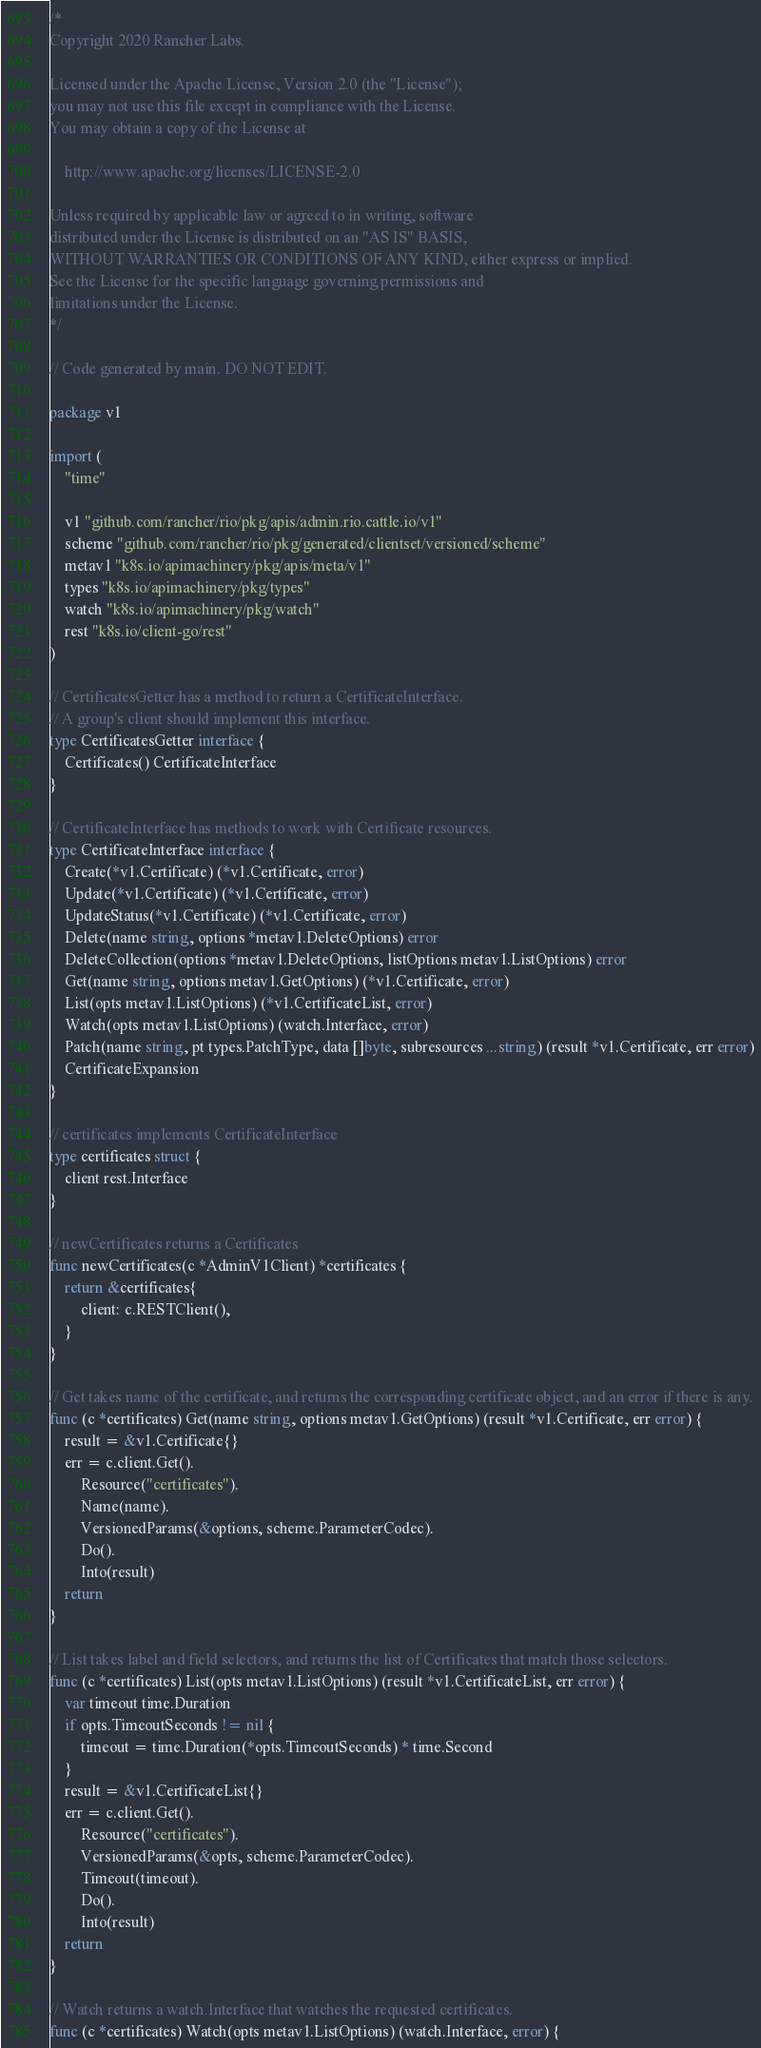Convert code to text. <code><loc_0><loc_0><loc_500><loc_500><_Go_>/*
Copyright 2020 Rancher Labs.

Licensed under the Apache License, Version 2.0 (the "License");
you may not use this file except in compliance with the License.
You may obtain a copy of the License at

    http://www.apache.org/licenses/LICENSE-2.0

Unless required by applicable law or agreed to in writing, software
distributed under the License is distributed on an "AS IS" BASIS,
WITHOUT WARRANTIES OR CONDITIONS OF ANY KIND, either express or implied.
See the License for the specific language governing permissions and
limitations under the License.
*/

// Code generated by main. DO NOT EDIT.

package v1

import (
	"time"

	v1 "github.com/rancher/rio/pkg/apis/admin.rio.cattle.io/v1"
	scheme "github.com/rancher/rio/pkg/generated/clientset/versioned/scheme"
	metav1 "k8s.io/apimachinery/pkg/apis/meta/v1"
	types "k8s.io/apimachinery/pkg/types"
	watch "k8s.io/apimachinery/pkg/watch"
	rest "k8s.io/client-go/rest"
)

// CertificatesGetter has a method to return a CertificateInterface.
// A group's client should implement this interface.
type CertificatesGetter interface {
	Certificates() CertificateInterface
}

// CertificateInterface has methods to work with Certificate resources.
type CertificateInterface interface {
	Create(*v1.Certificate) (*v1.Certificate, error)
	Update(*v1.Certificate) (*v1.Certificate, error)
	UpdateStatus(*v1.Certificate) (*v1.Certificate, error)
	Delete(name string, options *metav1.DeleteOptions) error
	DeleteCollection(options *metav1.DeleteOptions, listOptions metav1.ListOptions) error
	Get(name string, options metav1.GetOptions) (*v1.Certificate, error)
	List(opts metav1.ListOptions) (*v1.CertificateList, error)
	Watch(opts metav1.ListOptions) (watch.Interface, error)
	Patch(name string, pt types.PatchType, data []byte, subresources ...string) (result *v1.Certificate, err error)
	CertificateExpansion
}

// certificates implements CertificateInterface
type certificates struct {
	client rest.Interface
}

// newCertificates returns a Certificates
func newCertificates(c *AdminV1Client) *certificates {
	return &certificates{
		client: c.RESTClient(),
	}
}

// Get takes name of the certificate, and returns the corresponding certificate object, and an error if there is any.
func (c *certificates) Get(name string, options metav1.GetOptions) (result *v1.Certificate, err error) {
	result = &v1.Certificate{}
	err = c.client.Get().
		Resource("certificates").
		Name(name).
		VersionedParams(&options, scheme.ParameterCodec).
		Do().
		Into(result)
	return
}

// List takes label and field selectors, and returns the list of Certificates that match those selectors.
func (c *certificates) List(opts metav1.ListOptions) (result *v1.CertificateList, err error) {
	var timeout time.Duration
	if opts.TimeoutSeconds != nil {
		timeout = time.Duration(*opts.TimeoutSeconds) * time.Second
	}
	result = &v1.CertificateList{}
	err = c.client.Get().
		Resource("certificates").
		VersionedParams(&opts, scheme.ParameterCodec).
		Timeout(timeout).
		Do().
		Into(result)
	return
}

// Watch returns a watch.Interface that watches the requested certificates.
func (c *certificates) Watch(opts metav1.ListOptions) (watch.Interface, error) {</code> 